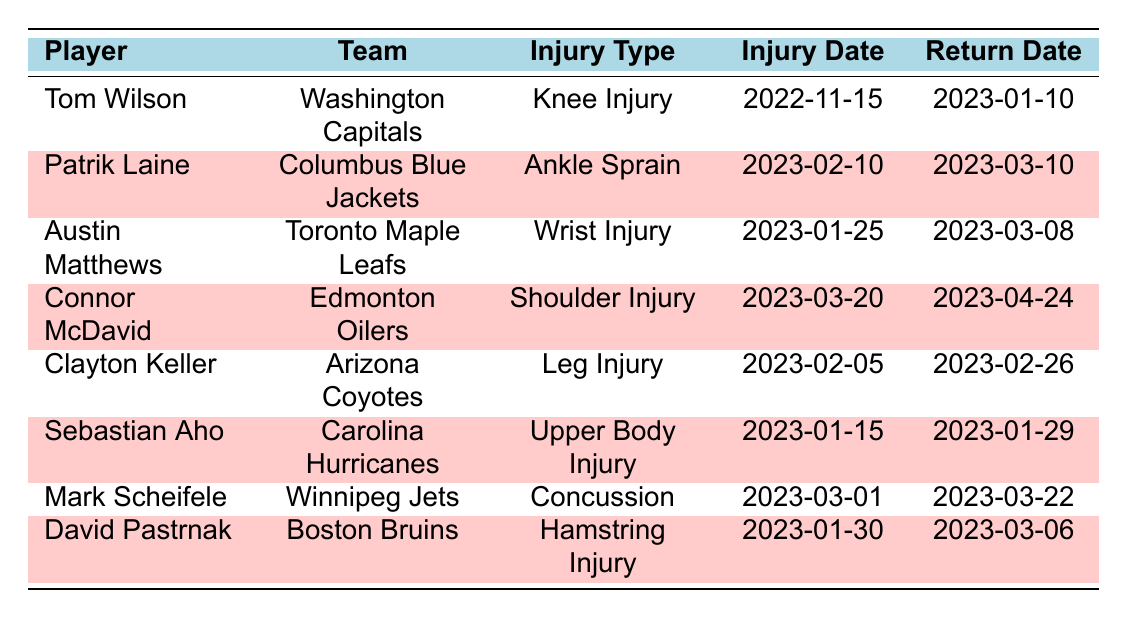What injury did Tom Wilson suffer? The table lists Tom Wilson's injury type as "Knee Injury."
Answer: Knee Injury When did Sebastian Aho injure himself? The injury date for Sebastian Aho is provided in the table as "2023-01-15."
Answer: 2023-01-15 What is the recovery time for Austin Matthews? The table shows that Austin Matthews has a recovery time of 6 weeks.
Answer: 6 weeks Who returned to play after the shortest recovery time? According to the table, Clayton Keller had a recovery time of 3 weeks, which is the shortest among all players listed.
Answer: Clayton Keller Did Connor McDavid return before or after April 20, 2023? The return date for Connor McDavid is "2023-04-24," which is after April 20, 2023.
Answer: After What is the difference in recovery time between David Pastrnak and Connor McDavid? David Pastrnak has a recovery time of 5 weeks, and Connor McDavid has a recovery time of 5 weeks. The difference is 5 - 5 = 0 weeks.
Answer: 0 weeks If Mark Scheifele returned on March 22, 2023, how many weeks after his injury date did he return? Mark Scheifele's injury date is "2023-03-01," and he returned on "2023-03-22." To find the difference, we count the days between these dates, which totals 3 weeks.
Answer: 3 weeks What percentage of players listed returned within 4 weeks of their injury? Clayton Keller and Sebastian Aho returned within 4 weeks. That's 2 out of 8 players, which is (2/8) * 100 = 25%.
Answer: 25% List the players who had a recovery time of 5 weeks or more. Examining the table, Tom Wilson (8 weeks), Connor McDavid (5 weeks), and David Pastrnak (5 weeks) had recovery times of 5 weeks or more.
Answer: Tom Wilson, Connor McDavid, David Pastrnak Which player from the table had a concussion? The table indicates that Mark Scheifele suffered a concussion.
Answer: Mark Scheifele What is the maximum recovery time listed for any player? The table shows that Tom Wilson has the maximum recovery time of 8 weeks.
Answer: 8 weeks 